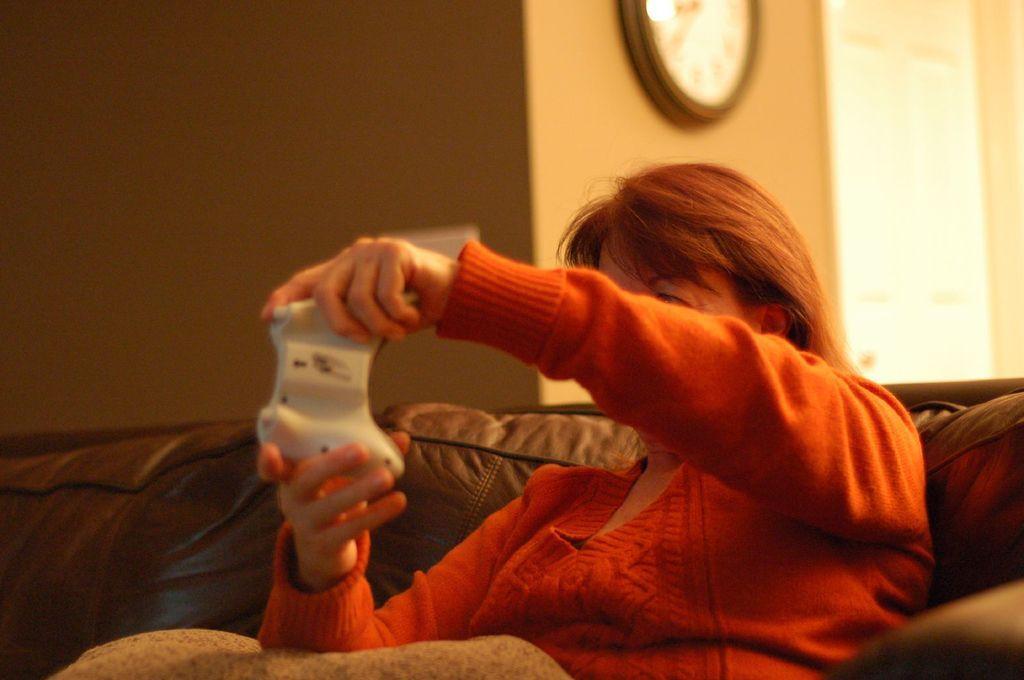How would you summarize this image in a sentence or two? As we can see in the image there is wall, clock, a woman wearing red color dress and sitting on sofa. 